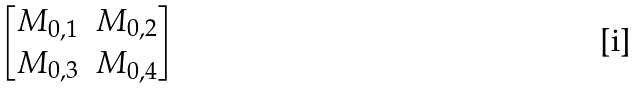Convert formula to latex. <formula><loc_0><loc_0><loc_500><loc_500>\begin{bmatrix} M _ { 0 , 1 } & M _ { 0 , 2 } \\ M _ { 0 , 3 } & M _ { 0 , 4 } \end{bmatrix}</formula> 